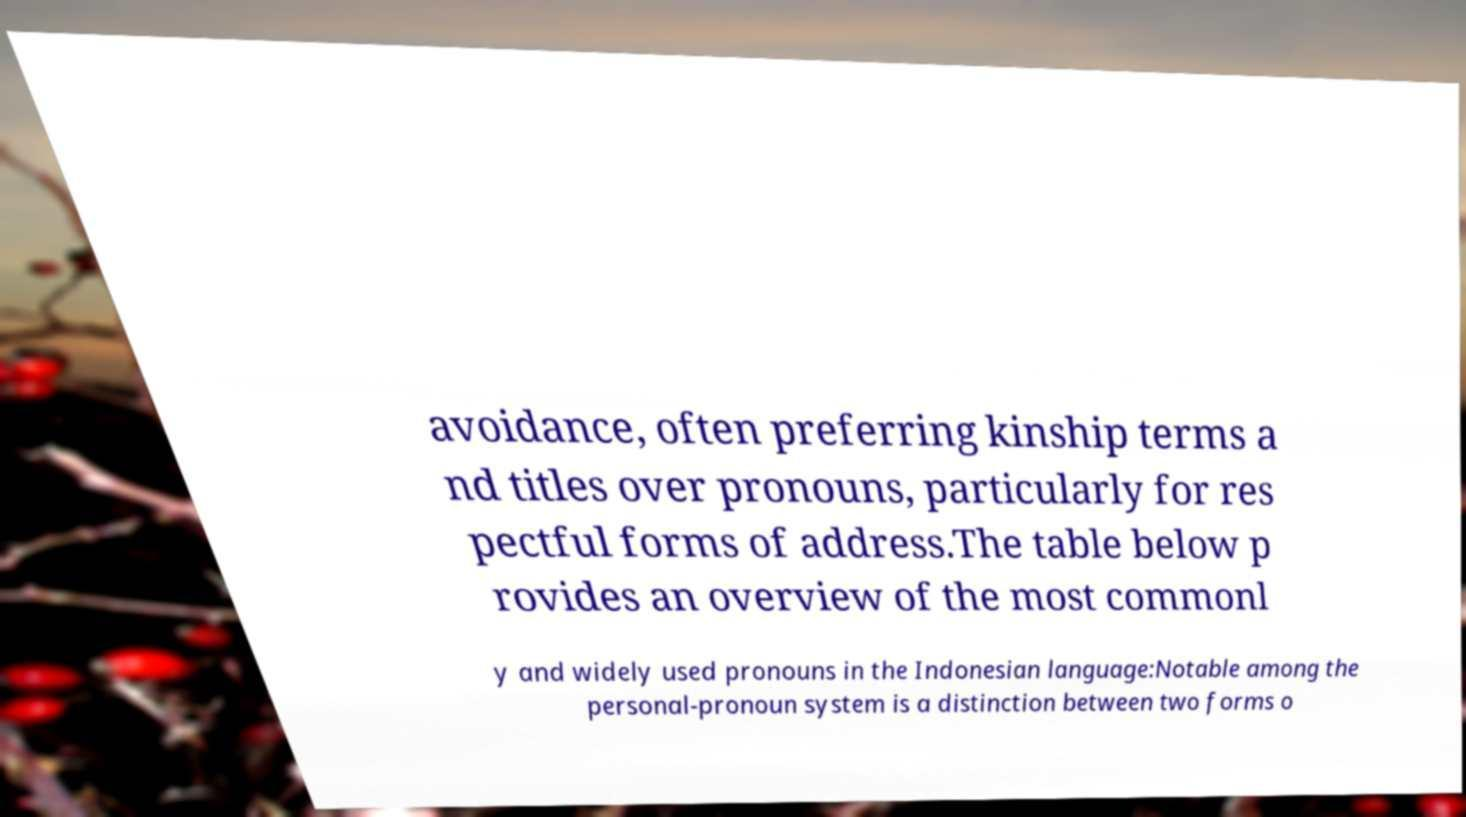Please read and relay the text visible in this image. What does it say? avoidance, often preferring kinship terms a nd titles over pronouns, particularly for res pectful forms of address.The table below p rovides an overview of the most commonl y and widely used pronouns in the Indonesian language:Notable among the personal-pronoun system is a distinction between two forms o 